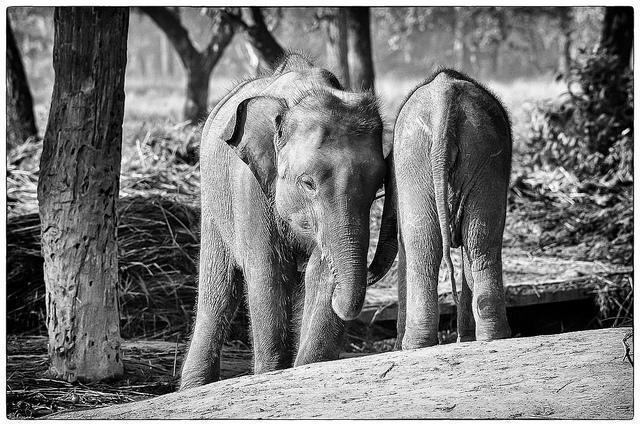How many elephants are in the picture?
Give a very brief answer. 2. 